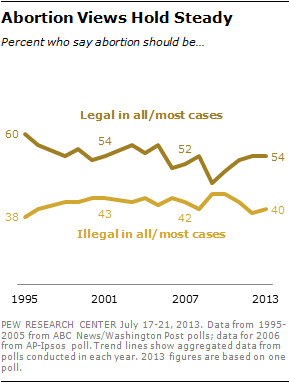Highlight a few significant elements in this photo. The minimum value of the line on top is 38. The maximum value of the line on top is 60. 